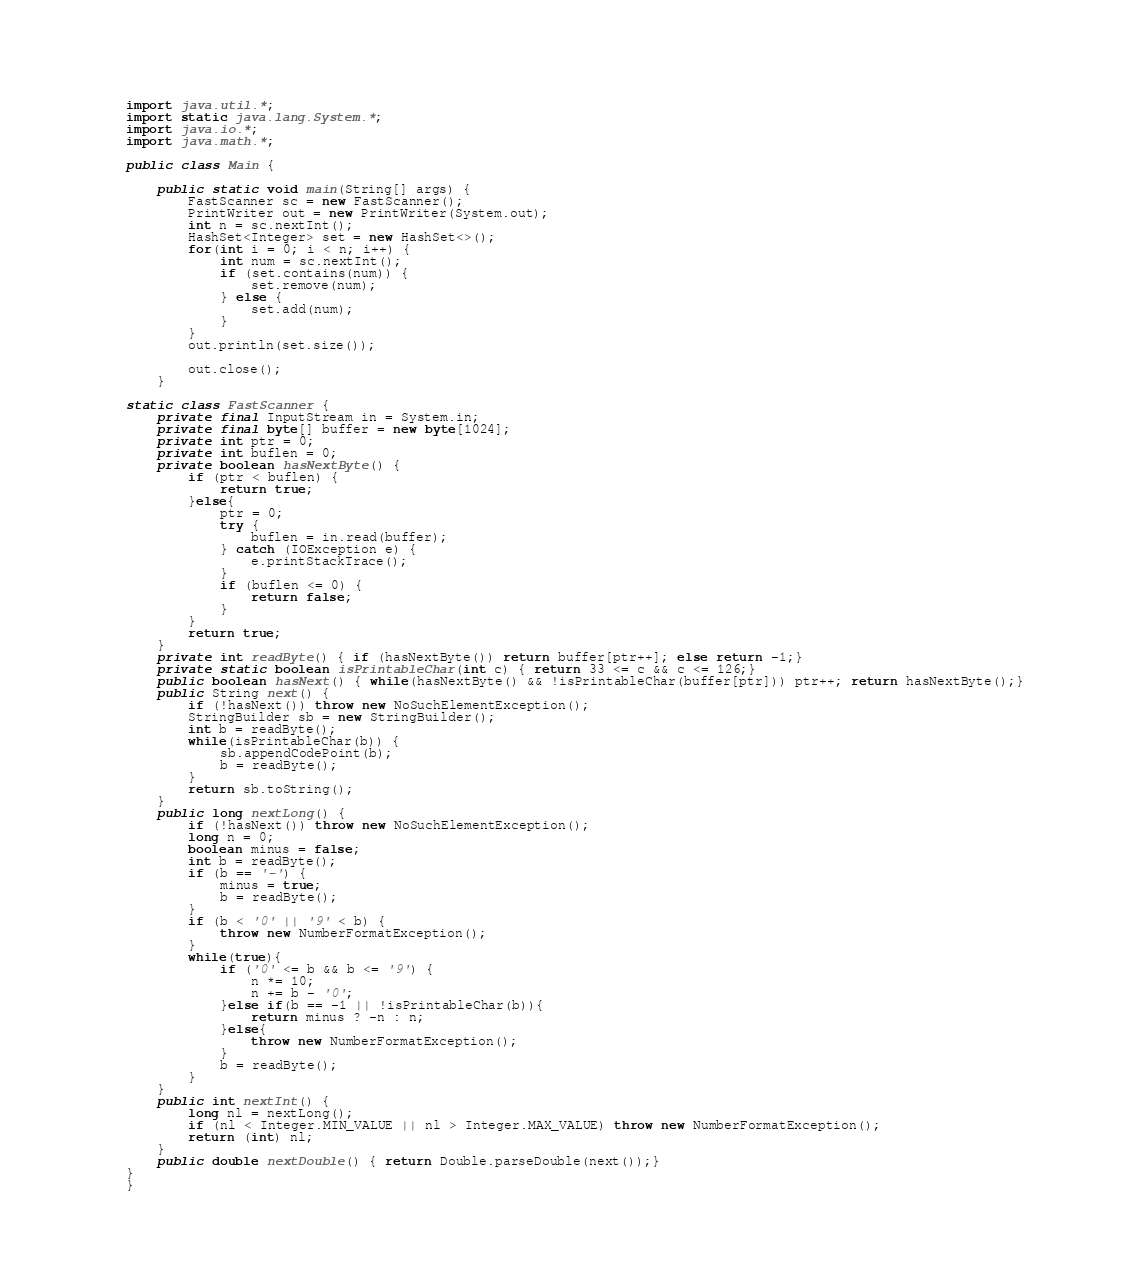<code> <loc_0><loc_0><loc_500><loc_500><_Java_>import java.util.*;
import static java.lang.System.*;
import java.io.*;
import java.math.*;

public class Main {

	public static void main(String[] args) {
		FastScanner sc = new FastScanner();
		PrintWriter out = new PrintWriter(System.out);
		int n = sc.nextInt();
		HashSet<Integer> set = new HashSet<>();
		for(int i = 0; i < n; i++) {
			int num = sc.nextInt();
			if (set.contains(num)) {
				set.remove(num);
			} else {
				set.add(num);
			}
		}
		out.println(set.size());

		out.close();
	}

static class FastScanner {
    private final InputStream in = System.in;
    private final byte[] buffer = new byte[1024];
    private int ptr = 0;
    private int buflen = 0;
    private boolean hasNextByte() {
        if (ptr < buflen) {
            return true;
        }else{
            ptr = 0;
            try {
                buflen = in.read(buffer);
            } catch (IOException e) {
                e.printStackTrace();
            }
            if (buflen <= 0) {
                return false;
            }
        }
        return true;
    }
    private int readByte() { if (hasNextByte()) return buffer[ptr++]; else return -1;}
    private static boolean isPrintableChar(int c) { return 33 <= c && c <= 126;}
    public boolean hasNext() { while(hasNextByte() && !isPrintableChar(buffer[ptr])) ptr++; return hasNextByte();}
    public String next() {
        if (!hasNext()) throw new NoSuchElementException();
        StringBuilder sb = new StringBuilder();
        int b = readByte();
        while(isPrintableChar(b)) {
            sb.appendCodePoint(b);
            b = readByte();
        }
        return sb.toString();
    }
    public long nextLong() {
        if (!hasNext()) throw new NoSuchElementException();
        long n = 0;
        boolean minus = false;
        int b = readByte();
        if (b == '-') {
            minus = true;
            b = readByte();
        }
        if (b < '0' || '9' < b) {
            throw new NumberFormatException();
        }
        while(true){
            if ('0' <= b && b <= '9') {
                n *= 10;
                n += b - '0';
            }else if(b == -1 || !isPrintableChar(b)){
                return minus ? -n : n;
            }else{
                throw new NumberFormatException();
            }
            b = readByte();
        }
    }
    public int nextInt() {
        long nl = nextLong();
        if (nl < Integer.MIN_VALUE || nl > Integer.MAX_VALUE) throw new NumberFormatException();
        return (int) nl;
    }
    public double nextDouble() { return Double.parseDouble(next());}
}
}</code> 